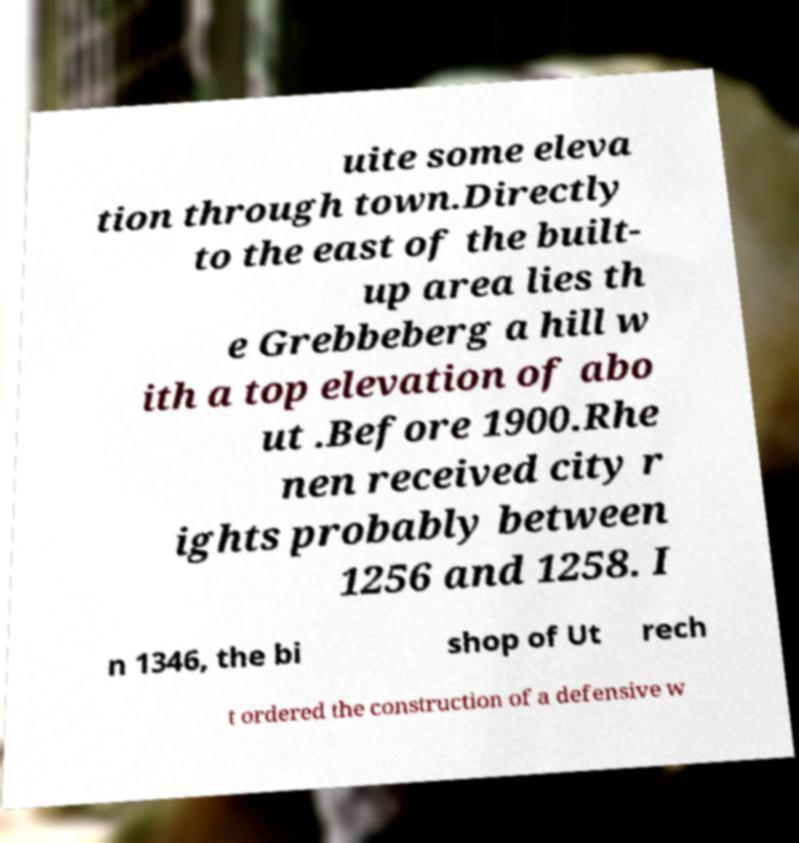Please identify and transcribe the text found in this image. uite some eleva tion through town.Directly to the east of the built- up area lies th e Grebbeberg a hill w ith a top elevation of abo ut .Before 1900.Rhe nen received city r ights probably between 1256 and 1258. I n 1346, the bi shop of Ut rech t ordered the construction of a defensive w 